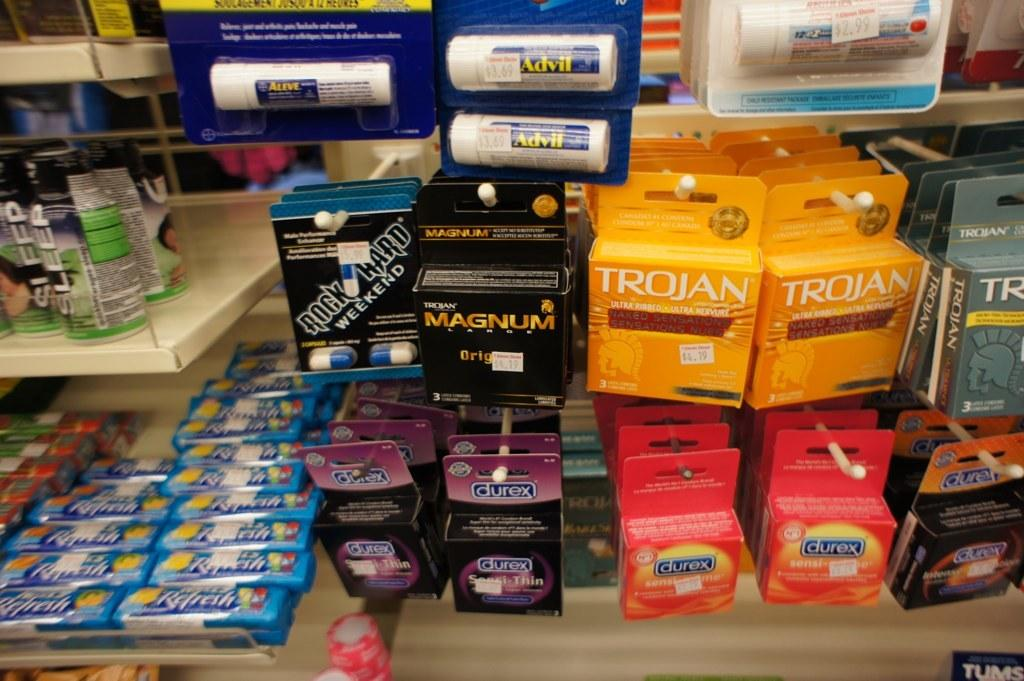Provide a one-sentence caption for the provided image. Several condom packages are on hooks at the store, including Trojan and Magnum brands. 